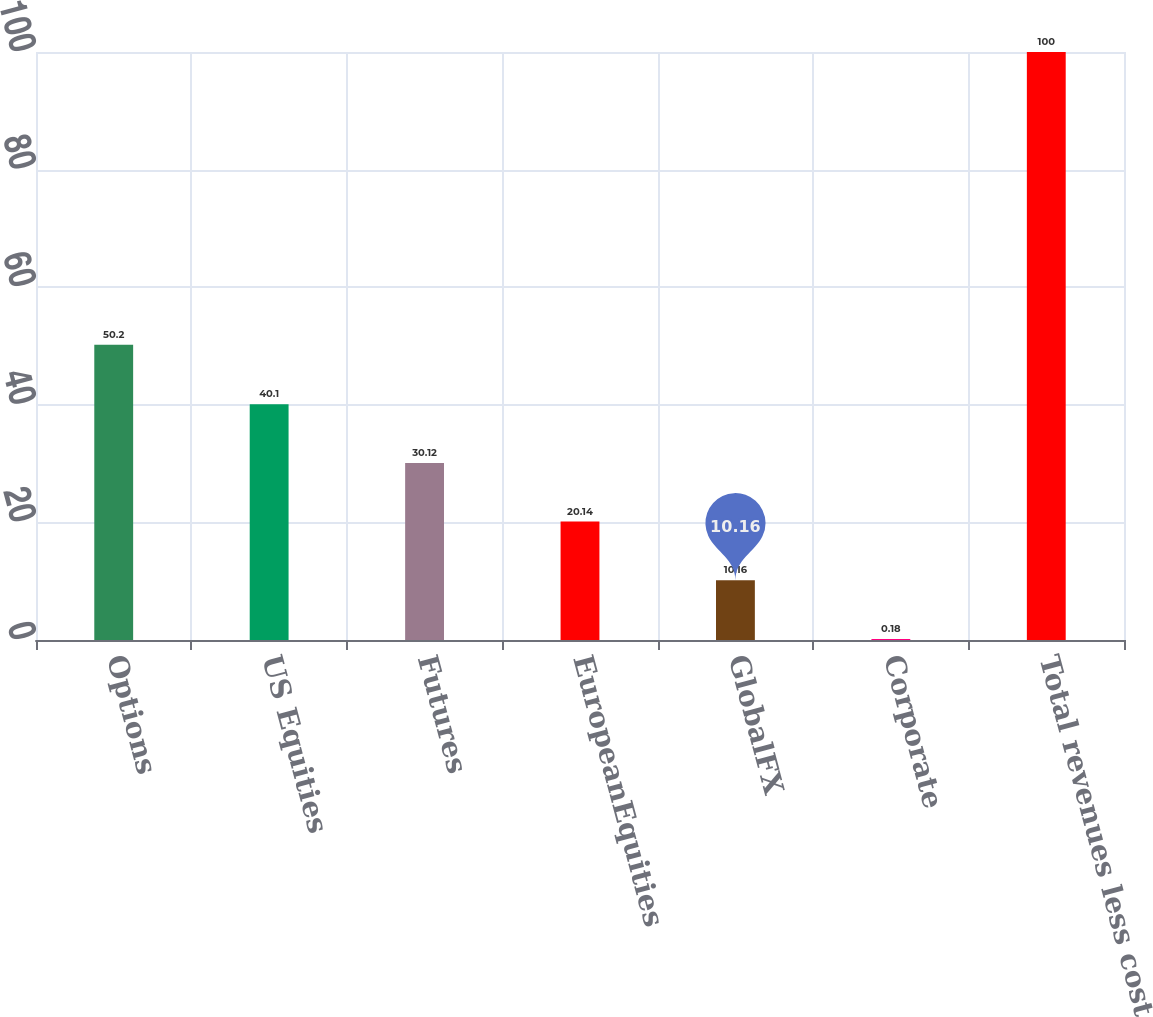<chart> <loc_0><loc_0><loc_500><loc_500><bar_chart><fcel>Options<fcel>US Equities<fcel>Futures<fcel>EuropeanEquities<fcel>GlobalFX<fcel>Corporate<fcel>Total revenues less cost<nl><fcel>50.2<fcel>40.1<fcel>30.12<fcel>20.14<fcel>10.16<fcel>0.18<fcel>100<nl></chart> 